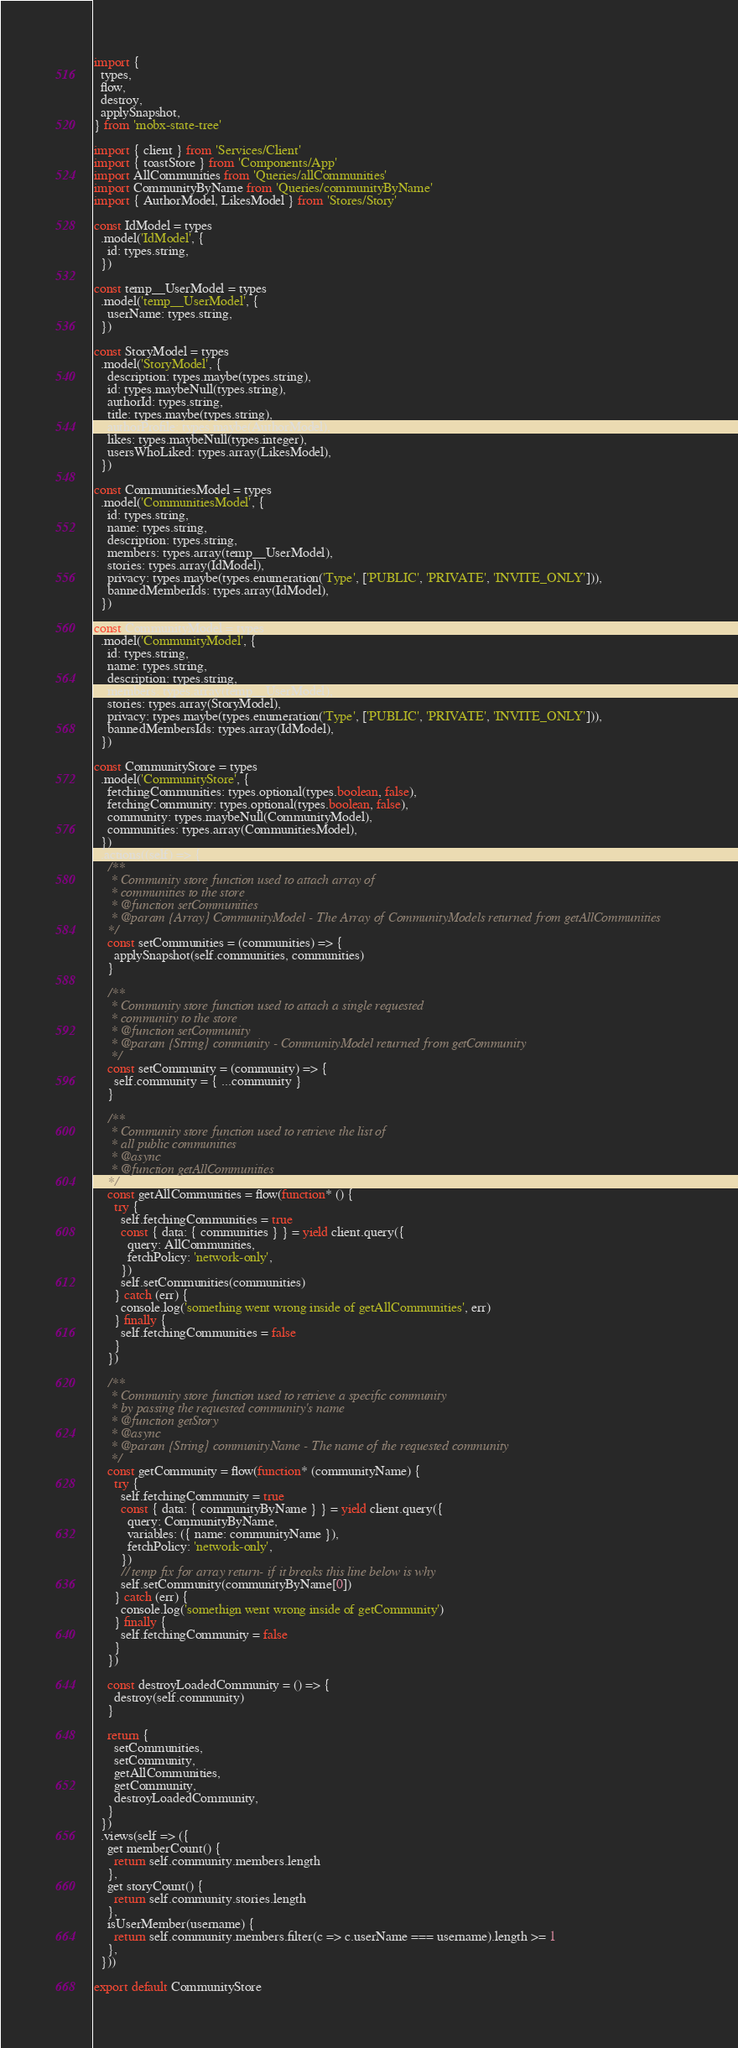<code> <loc_0><loc_0><loc_500><loc_500><_JavaScript_>import {
  types,
  flow,
  destroy,
  applySnapshot,
} from 'mobx-state-tree'

import { client } from 'Services/Client'
import { toastStore } from 'Components/App'
import AllCommunities from 'Queries/allCommunities'
import CommunityByName from 'Queries/communityByName'
import { AuthorModel, LikesModel } from 'Stores/Story'

const IdModel = types
  .model('IdModel', {
    id: types.string,
  })

const temp__UserModel = types
  .model('temp__UserModel', {
    userName: types.string,
  })

const StoryModel = types
  .model('StoryModel', {
    description: types.maybe(types.string),
    id: types.maybeNull(types.string),
    authorId: types.string,
    title: types.maybe(types.string),
    authorProfile: types.maybe(AuthorModel),
    likes: types.maybeNull(types.integer),
    usersWhoLiked: types.array(LikesModel),
  })

const CommunitiesModel = types
  .model('CommunitiesModel', {
    id: types.string,
    name: types.string,
    description: types.string,
    members: types.array(temp__UserModel),
    stories: types.array(IdModel),
    privacy: types.maybe(types.enumeration('Type', ['PUBLIC', 'PRIVATE', 'INVITE_ONLY'])),
    bannedMemberIds: types.array(IdModel),
  })

const CommunityModel = types
  .model('CommunityModel', {
    id: types.string,
    name: types.string,
    description: types.string,
    members: types.array(temp__UserModel),
    stories: types.array(StoryModel),
    privacy: types.maybe(types.enumeration('Type', ['PUBLIC', 'PRIVATE', 'INVITE_ONLY'])),
    bannedMembersIds: types.array(IdModel),
  })

const CommunityStore = types
  .model('CommunityStore', {
    fetchingCommunities: types.optional(types.boolean, false),
    fetchingCommunity: types.optional(types.boolean, false),
    community: types.maybeNull(CommunityModel),
    communities: types.array(CommunitiesModel),
  })
  .actions((self) => {
    /**
     * Community store function used to attach array of
     * communities to the store
     * @function setCommunities
     * @param {Array} CommunityModel - The Array of CommunityModels returned from getAllCommunities
    */
    const setCommunities = (communities) => {
      applySnapshot(self.communities, communities)
    }

    /**
     * Community store function used to attach a single requested
     * community to the store
     * @function setCommunity
     * @param {String} community - CommunityModel returned from getCommunity
     */
    const setCommunity = (community) => {
      self.community = { ...community }
    }

    /**
     * Community store function used to retrieve the list of
     * all public communities
     * @async
     * @function getAllCommunities
    */
    const getAllCommunities = flow(function* () {
      try {
        self.fetchingCommunities = true
        const { data: { communities } } = yield client.query({
          query: AllCommunities,
          fetchPolicy: 'network-only',
        })
        self.setCommunities(communities)
      } catch (err) {
        console.log('something went wrong inside of getAllCommunities', err)
      } finally {
        self.fetchingCommunities = false
      }
    })

    /**
     * Community store function used to retrieve a specific community
     * by passing the requested community's name
     * @function getStory
     * @async
     * @param {String} communityName - The name of the requested community
     */
    const getCommunity = flow(function* (communityName) {
      try {
        self.fetchingCommunity = true
        const { data: { communityByName } } = yield client.query({
          query: CommunityByName,
          variables: ({ name: communityName }),
          fetchPolicy: 'network-only',
        })
        // temp fix for array return- if it breaks this line below is why
        self.setCommunity(communityByName[0])
      } catch (err) {
        console.log('somethign went wrong inside of getCommunity')
      } finally {
        self.fetchingCommunity = false
      }
    })

    const destroyLoadedCommunity = () => {
      destroy(self.community)
    }

    return {
      setCommunities,
      setCommunity,
      getAllCommunities,
      getCommunity,
      destroyLoadedCommunity,
    }
  })
  .views(self => ({
    get memberCount() {
      return self.community.members.length
    },
    get storyCount() {
      return self.community.stories.length
    },
    isUserMember(username) {
      return self.community.members.filter(c => c.userName === username).length >= 1
    },
  }))

export default CommunityStore
</code> 